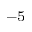Convert formula to latex. <formula><loc_0><loc_0><loc_500><loc_500>^ { - 5 }</formula> 